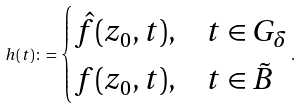Convert formula to latex. <formula><loc_0><loc_0><loc_500><loc_500>h ( t ) \colon = \begin{cases} \hat { f } ( z _ { 0 } , t ) , & t \in G _ { \delta } \\ f ( z _ { 0 } , t ) , & t \in \tilde { B } \end{cases} .</formula> 